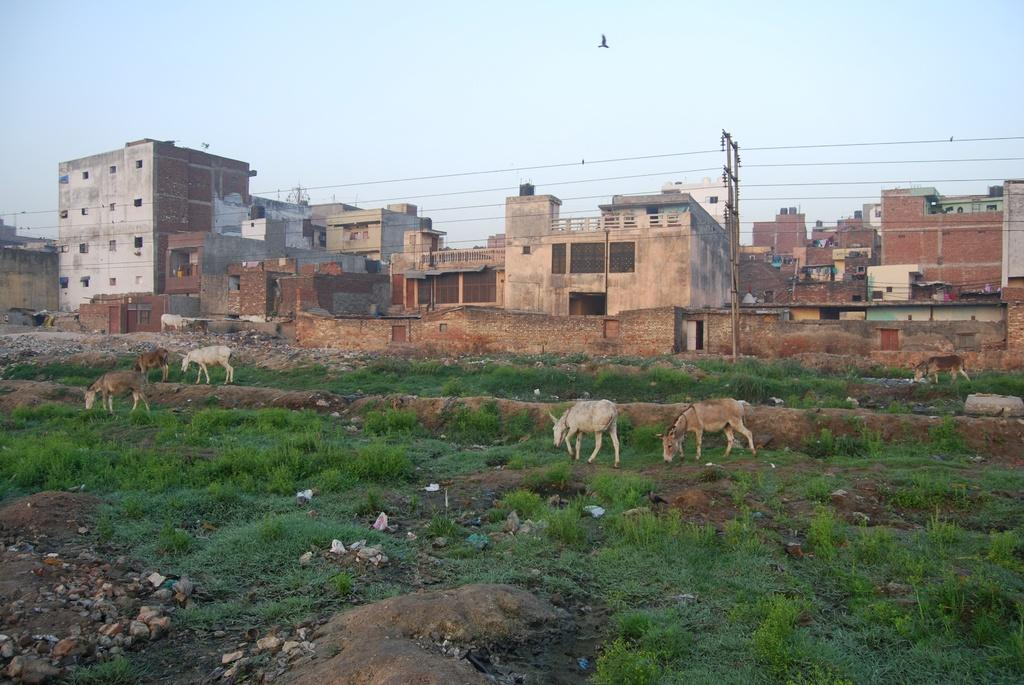What types of living organisms can be seen in the image? There are animals in the image. What type of vegetation is present in the image? There is grass in the image. Where are the animals located in relation to the ground? The animals are on the land. What can be seen in the background of the image? There are buildings, a pole, and wires in the background of the image. What is visible in the sky at the top of the image? There is a bird in the sky at the top of the image. Can you tell me how many kitties are playing with a slip in the image? There are no kitties or slips present in the image. Is there a squirrel climbing the pole in the background of the image? There is no squirrel climbing the pole in the background of the image. 